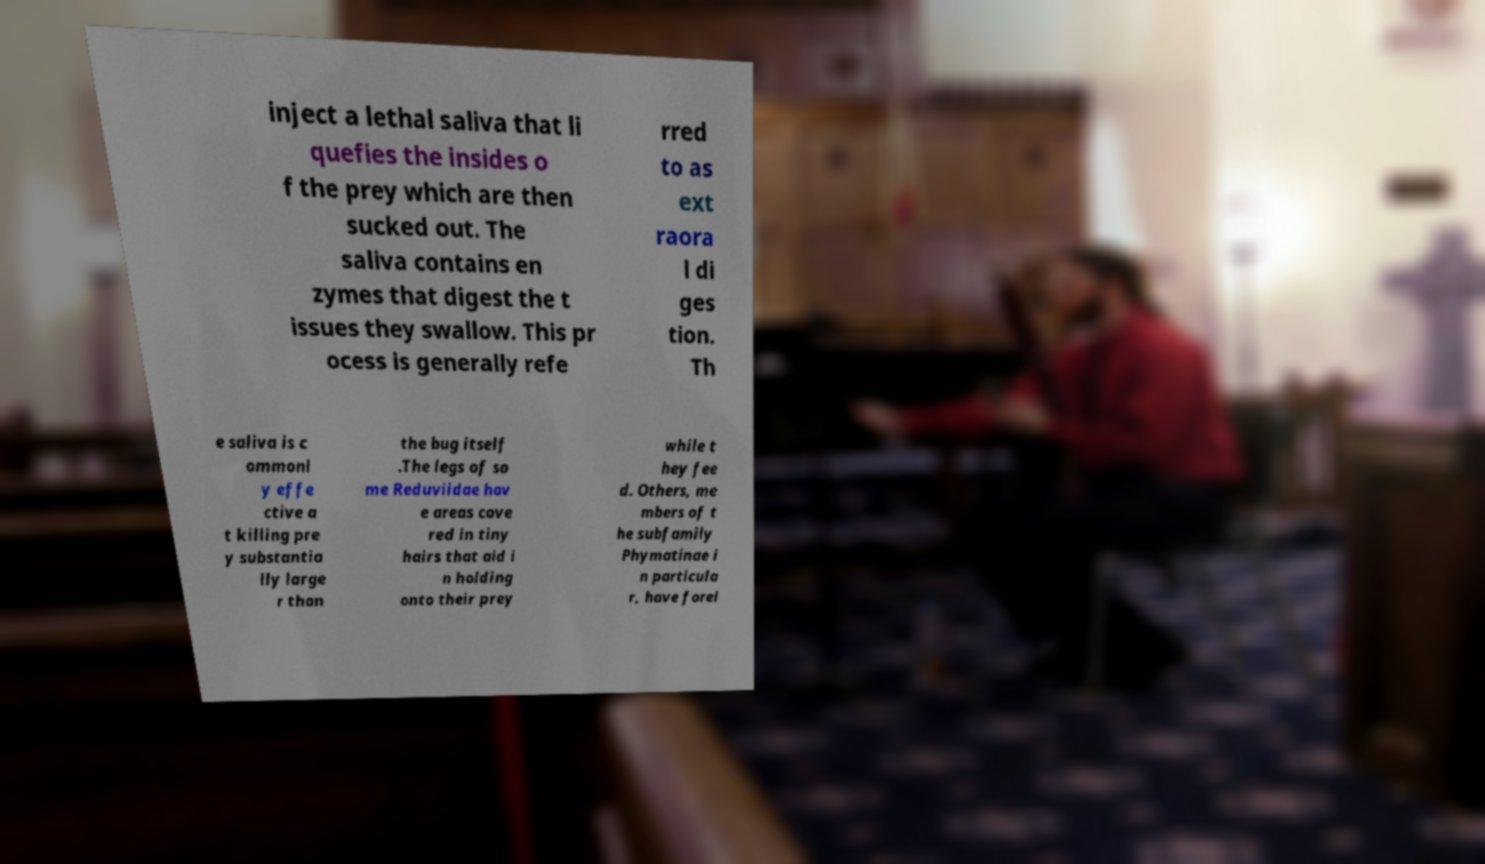There's text embedded in this image that I need extracted. Can you transcribe it verbatim? inject a lethal saliva that li quefies the insides o f the prey which are then sucked out. The saliva contains en zymes that digest the t issues they swallow. This pr ocess is generally refe rred to as ext raora l di ges tion. Th e saliva is c ommonl y effe ctive a t killing pre y substantia lly large r than the bug itself .The legs of so me Reduviidae hav e areas cove red in tiny hairs that aid i n holding onto their prey while t hey fee d. Others, me mbers of t he subfamily Phymatinae i n particula r, have forel 